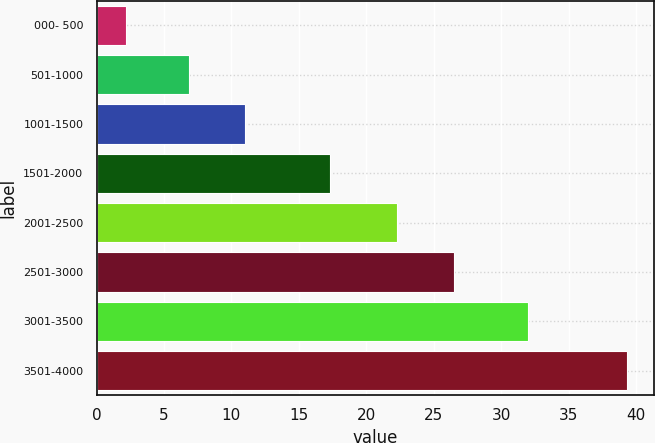<chart> <loc_0><loc_0><loc_500><loc_500><bar_chart><fcel>000- 500<fcel>501-1000<fcel>1001-1500<fcel>1501-2000<fcel>2001-2500<fcel>2501-3000<fcel>3001-3500<fcel>3501-4000<nl><fcel>2.2<fcel>6.89<fcel>11.02<fcel>17.3<fcel>22.26<fcel>26.51<fcel>31.98<fcel>39.35<nl></chart> 